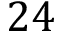Convert formula to latex. <formula><loc_0><loc_0><loc_500><loc_500>2 4</formula> 